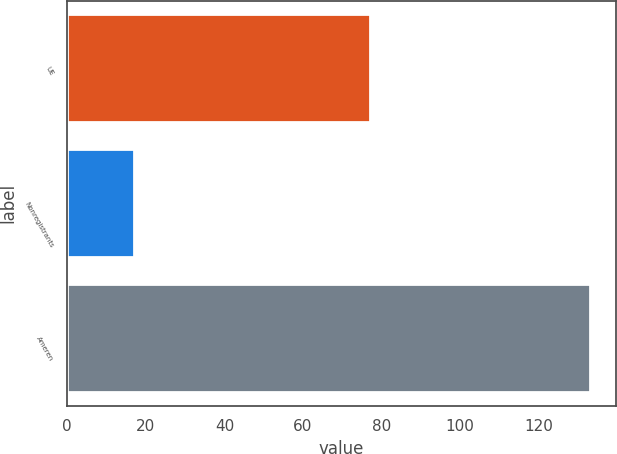<chart> <loc_0><loc_0><loc_500><loc_500><bar_chart><fcel>UE<fcel>Nonregistrants<fcel>Ameren<nl><fcel>77<fcel>17<fcel>133<nl></chart> 